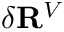Convert formula to latex. <formula><loc_0><loc_0><loc_500><loc_500>\delta R ^ { V }</formula> 